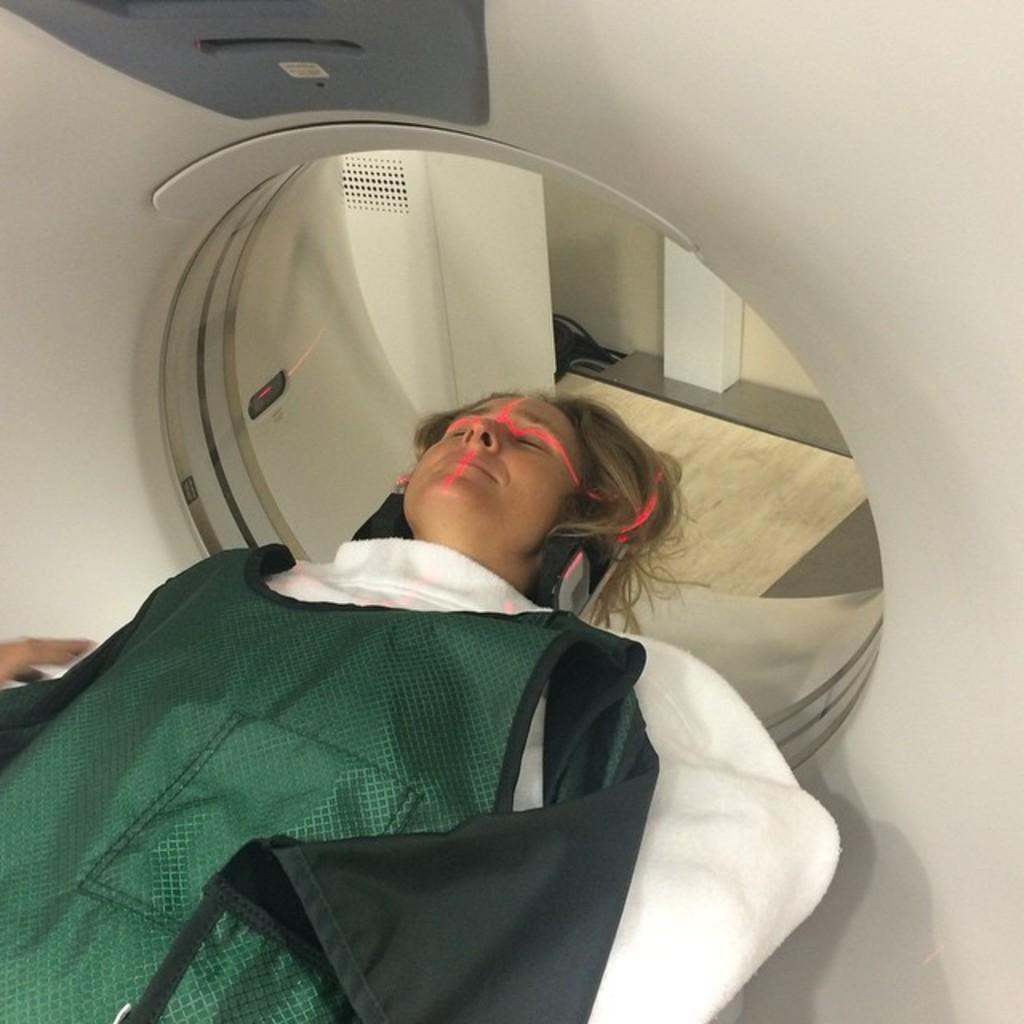What is the woman doing in the image? The woman is lying on the bed in the image. What type of medical equipment is present in the image? There is a full body CT scan machine in the image. What type of spoon is the woman using to eat in the image? There is no spoon present in the image, and the woman is not eating. Can you see any wilderness or natural landscapes in the image? No, the image does not depict any wilderness or natural landscapes; it features a woman lying on a bed and a full body CT scan machine. Are there any rings or jewelry visible on the woman in the image? There is no mention of rings or jewelry in the provided facts, so it cannot be determined if any are visible on the woman in the image. 